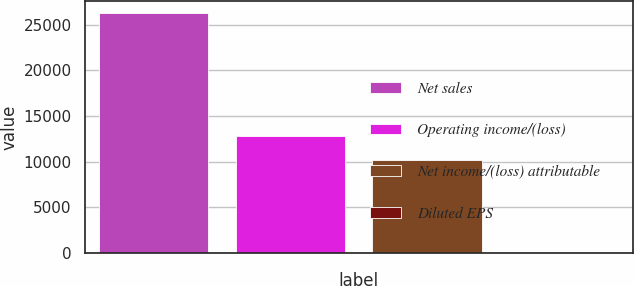Convert chart to OTSL. <chart><loc_0><loc_0><loc_500><loc_500><bar_chart><fcel>Net sales<fcel>Operating income/(loss)<fcel>Net income/(loss) attributable<fcel>Diluted EPS<nl><fcel>26268<fcel>12818<fcel>10192<fcel>8.36<nl></chart> 